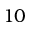<formula> <loc_0><loc_0><loc_500><loc_500>1 0</formula> 